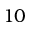<formula> <loc_0><loc_0><loc_500><loc_500>1 0</formula> 